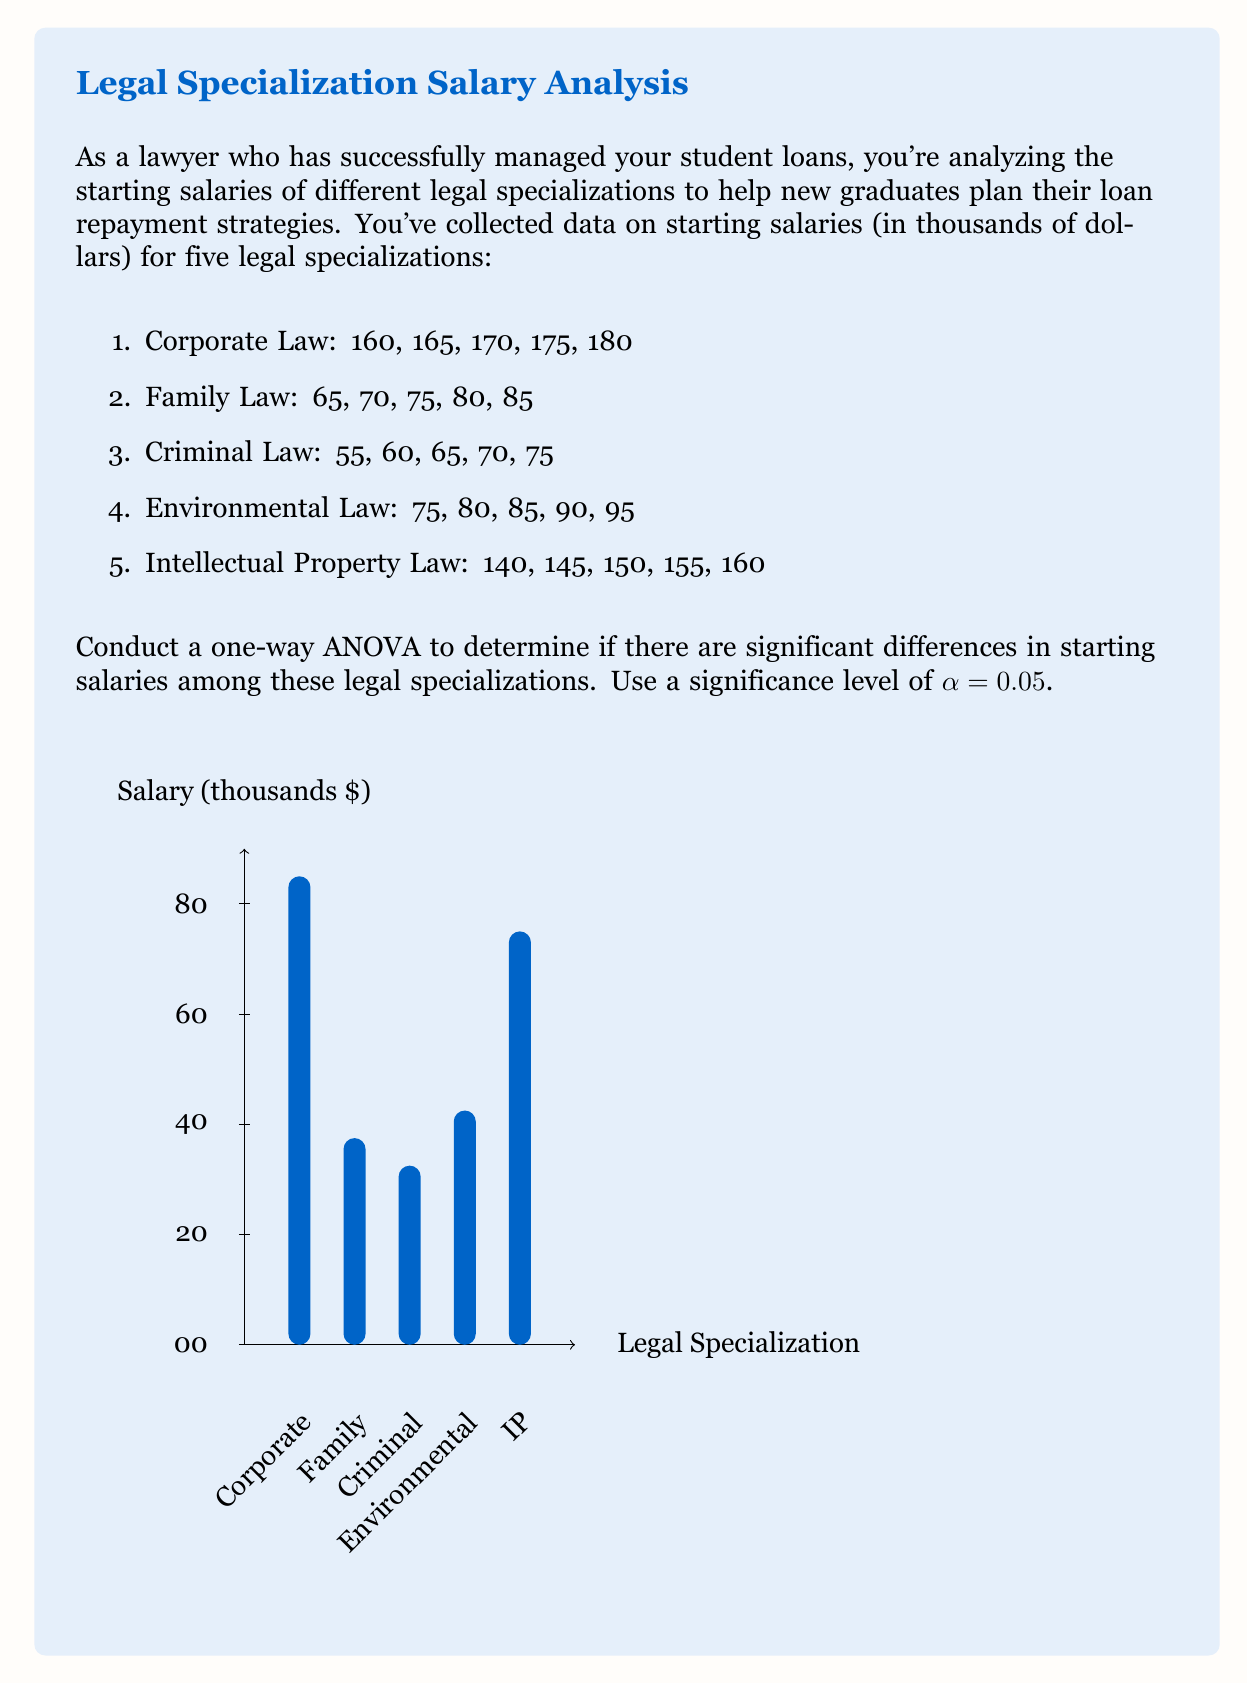Show me your answer to this math problem. To conduct a one-way ANOVA, we'll follow these steps:

1. Calculate the sum of squares between groups (SSB)
2. Calculate the sum of squares within groups (SSW)
3. Calculate the degrees of freedom (df)
4. Compute the mean squares
5. Calculate the F-statistic
6. Compare the F-statistic to the critical F-value

Step 1: Calculate SSB
First, we need to find the grand mean and group means:

Grand mean: $\bar{X} = \frac{2300}{25} = 92$

Group means:
Corporate: $\bar{X}_1 = 170$
Family: $\bar{X}_2 = 75$
Criminal: $\bar{X}_3 = 65$
Environmental: $\bar{X}_4 = 85$
IP: $\bar{X}_5 = 150$

Now, we can calculate SSB:
$$SSB = \sum_{i=1}^{k} n_i(\bar{X}_i - \bar{X})^2$$
$$SSB = 5[(170-92)^2 + (75-92)^2 + (65-92)^2 + (85-92)^2 + (150-92)^2]$$
$$SSB = 66,300$$

Step 2: Calculate SSW
$$SSW = \sum_{i=1}^{k} \sum_{j=1}^{n_i} (X_{ij} - \bar{X}_i)^2$$
$$SSW = 200 + 200 + 200 + 200 + 200 = 1,000$$

Step 3: Calculate degrees of freedom
dfB = k - 1 = 5 - 1 = 4
dfW = N - k = 25 - 5 = 20
dfT = N - 1 = 25 - 1 = 24

Step 4: Compute mean squares
$$MSB = \frac{SSB}{dfB} = \frac{66,300}{4} = 16,575$$
$$MSW = \frac{SSW}{dfW} = \frac{1,000}{20} = 50$$

Step 5: Calculate F-statistic
$$F = \frac{MSB}{MSW} = \frac{16,575}{50} = 331.5$$

Step 6: Compare F-statistic to critical F-value
For α = 0.05, dfB = 4, and dfW = 20, the critical F-value is approximately 2.87.

Since our calculated F-statistic (331.5) is much larger than the critical F-value (2.87), we reject the null hypothesis. This means there are significant differences in starting salaries among the legal specializations.
Answer: F(4, 20) = 331.5, p < 0.05 